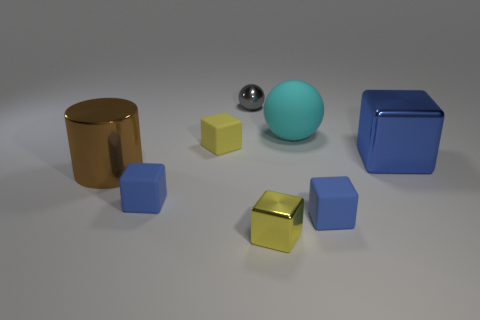There is a blue thing that is on the right side of the tiny yellow rubber thing and left of the large blue metallic block; what size is it?
Give a very brief answer. Small. How many other things are the same shape as the yellow metal object?
Give a very brief answer. 4. How many other objects are there of the same material as the small gray thing?
Your answer should be very brief. 3. What size is the other metallic thing that is the same shape as the large blue metal thing?
Your answer should be compact. Small. Does the tiny ball have the same color as the big rubber sphere?
Provide a short and direct response. No. What color is the block that is both behind the big metal cylinder and to the right of the cyan ball?
Your answer should be compact. Blue. What number of objects are either tiny matte objects that are left of the gray ball or small green metallic things?
Offer a very short reply. 2. There is a tiny metallic thing that is the same shape as the tiny yellow matte thing; what is its color?
Offer a very short reply. Yellow. Does the cyan rubber thing have the same shape as the small yellow object that is behind the big shiny block?
Your answer should be very brief. No. What number of things are either things that are in front of the large shiny block or tiny yellow things in front of the big shiny cylinder?
Give a very brief answer. 4. 